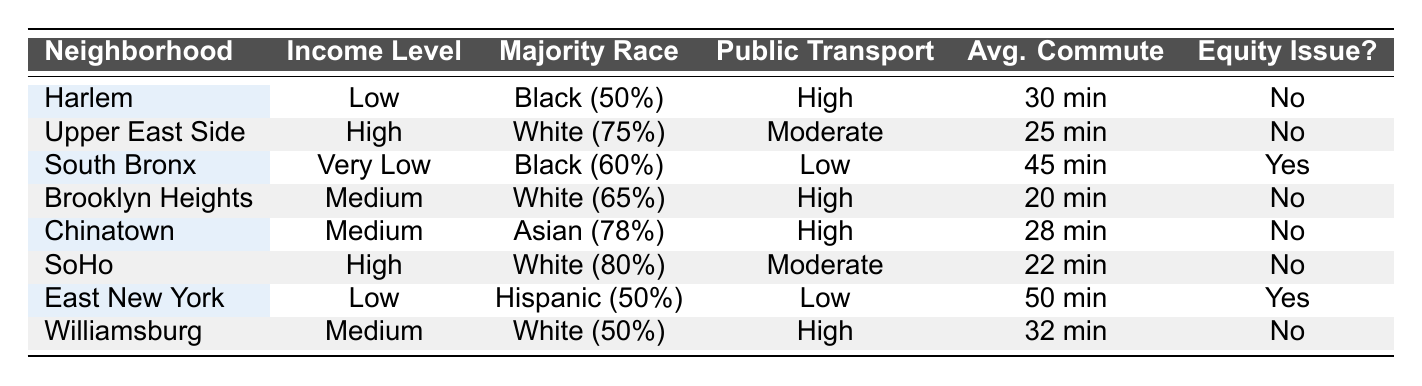What is the public transport accessibility level in Harlem? The table shows that for Harlem, the public transport accessibility is listed as "High."
Answer: High Which neighborhood has the highest percentage of Black residents? The South Bronx has the highest percentage of Black residents at 60%, as seen in the racial demographics section of the table.
Answer: South Bronx What is the average commute time in the Upper East Side? The average commute time in the Upper East Side is 25 minutes, according to the average commute time column in the table.
Answer: 25 min Is there an equity issue identified in East New York? The table indicates that East New York has an equity issue, as it is marked with "Yes" in that column.
Answer: Yes What is the difference in average commute times between neighborhoods with high and low public transport accessibility? High public transport accessibility neighborhoods (Harlem, Brooklyn Heights, Chinatown, Williamsburg) have average commute times of (30 + 20 + 28 + 32) / 4 = 27.5 min, while Low public transport neighborhoods (South Bronx, East New York) have (45 + 50) / 2 = 47.5 min. The difference is 47.5 - 27.5 = 20 min.
Answer: 20 min Which neighborhood has the lowest public transport accessibility? The South Bronx has the lowest public transport accessibility, categorized as "Low" in the table.
Answer: South Bronx How many neighborhoods have a majority white racial demographic? The neighborhoods with a majority white demographic are Upper East Side, Brooklyn Heights, SoHo, and Williamsburg, totaling 4 neighborhoods.
Answer: 4 In which neighborhoods does the average commute time exceed 30 minutes? The neighborhoods with average commute times exceeding 30 minutes are South Bronx (45 min) and East New York (50 min).
Answer: South Bronx, East New York Is there at least one neighborhood with a majority Hispanic population? Yes, the East New York neighborhood has a majority Hispanic population with 50%.
Answer: Yes 